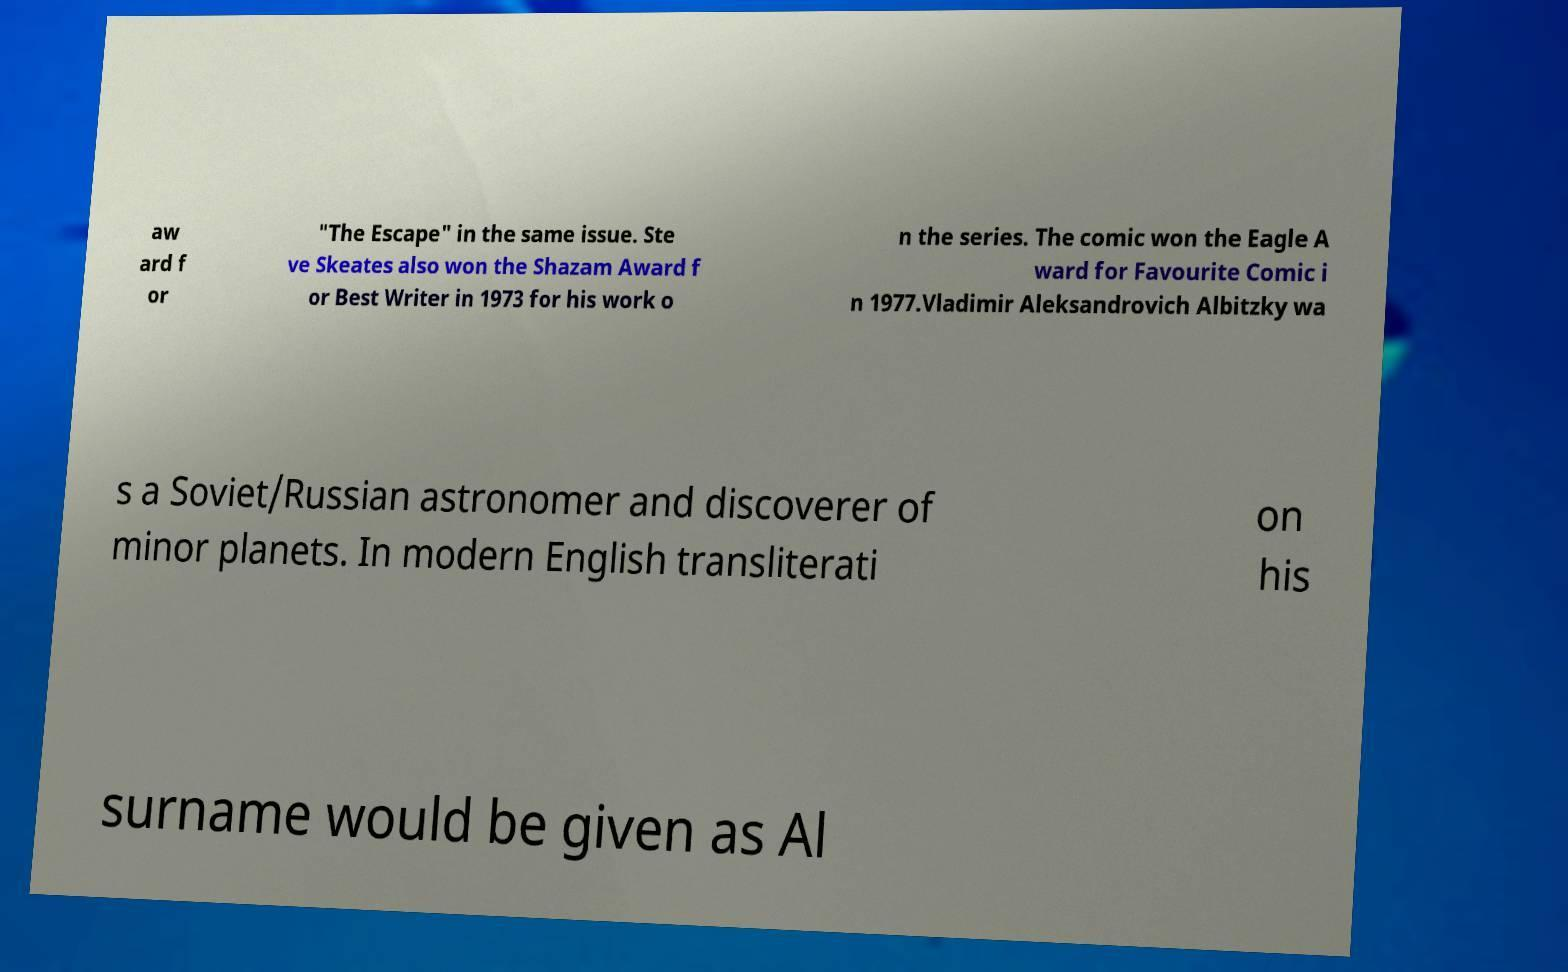Please read and relay the text visible in this image. What does it say? aw ard f or "The Escape" in the same issue. Ste ve Skeates also won the Shazam Award f or Best Writer in 1973 for his work o n the series. The comic won the Eagle A ward for Favourite Comic i n 1977.Vladimir Aleksandrovich Albitzky wa s a Soviet/Russian astronomer and discoverer of minor planets. In modern English transliterati on his surname would be given as Al 